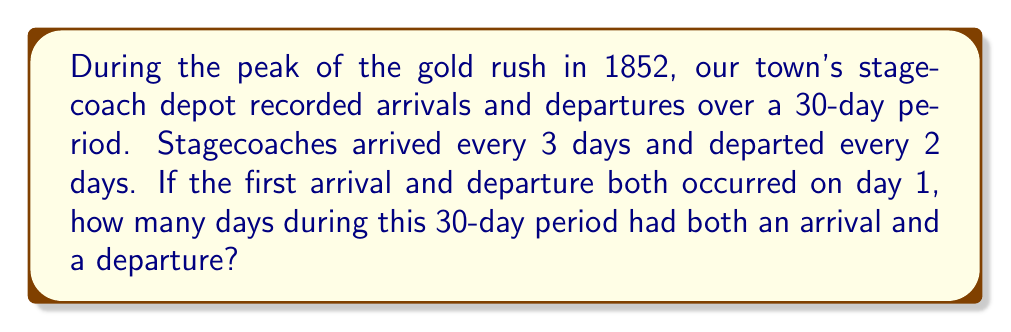Could you help me with this problem? To solve this problem, we need to find the least common multiple (LCM) of the arrival and departure frequencies, and then count how many times this occurs within the 30-day period.

1. Arrival frequency: every 3 days
2. Departure frequency: every 2 days

Let's find the LCM of 2 and 3:
$$ LCM(2,3) = 2 \times 3 = 6 $$

This means that every 6 days, there will be both an arrival and a departure.

Now, we need to determine how many complete 6-day cycles occur within 30 days:

$$ \text{Number of complete cycles} = \left\lfloor\frac{30}{6}\right\rfloor = 5 $$

Therefore, there are 5 days within the 30-day period where both an arrival and departure occur.

To verify:
- Day 1: Arrival and Departure
- Day 7: Arrival and Departure
- Day 13: Arrival and Departure
- Day 19: Arrival and Departure
- Day 25: Arrival and Departure
Answer: 5 days 